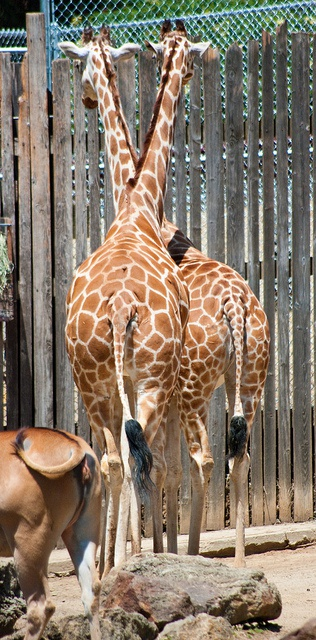Describe the objects in this image and their specific colors. I can see a giraffe in black, lightgray, gray, and tan tones in this image. 